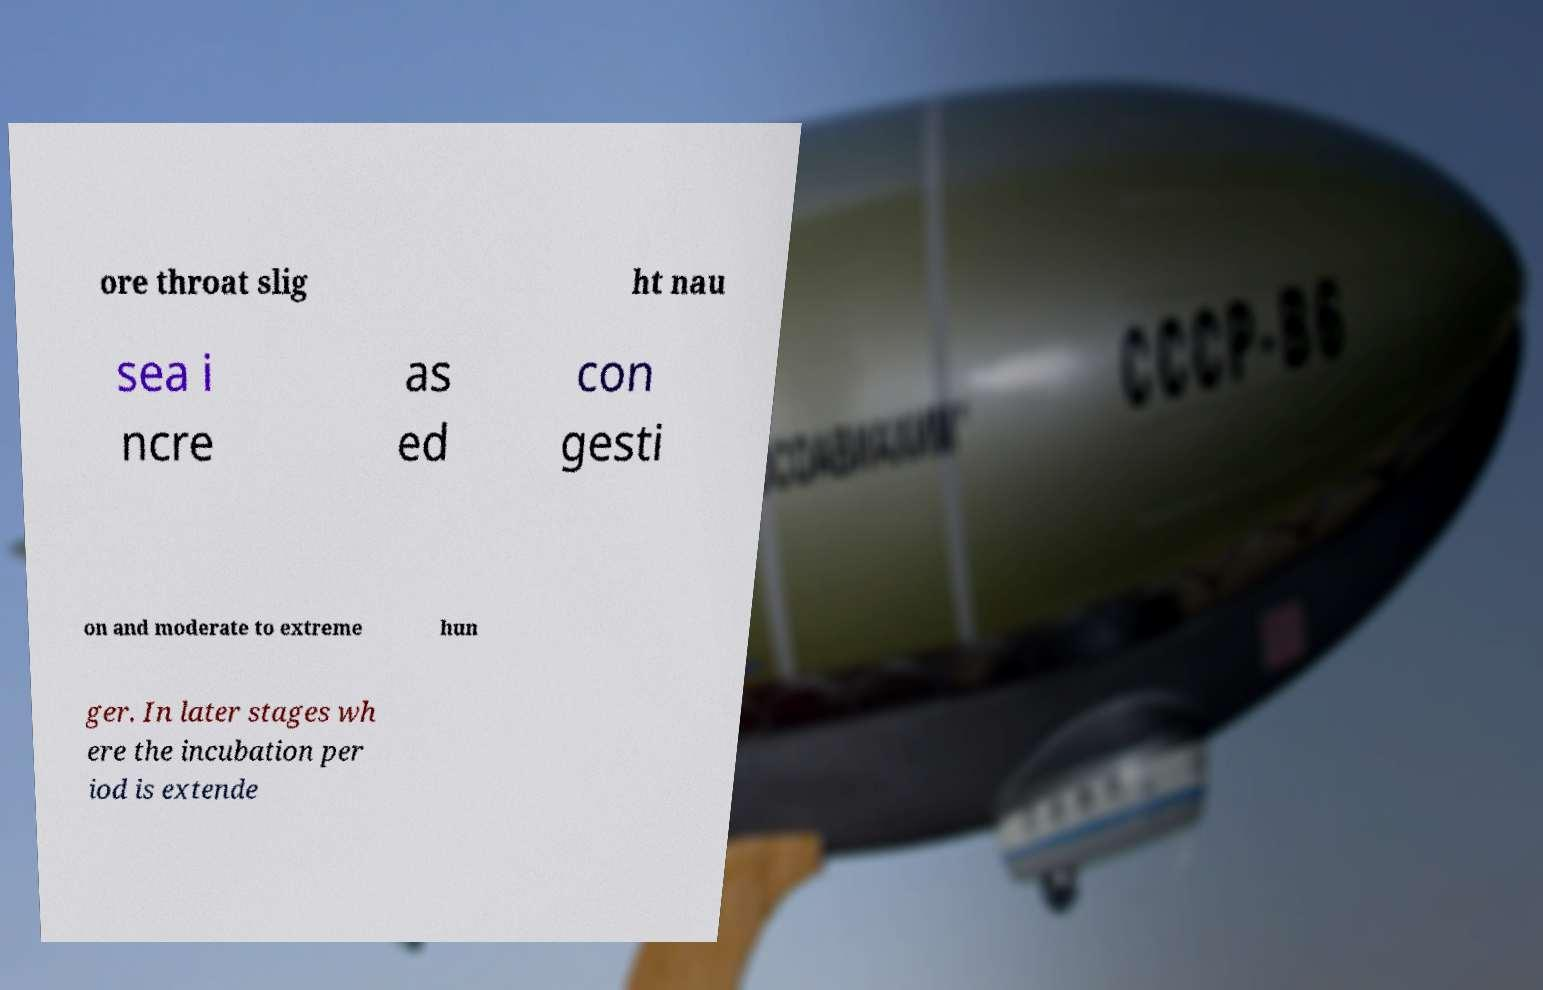I need the written content from this picture converted into text. Can you do that? ore throat slig ht nau sea i ncre as ed con gesti on and moderate to extreme hun ger. In later stages wh ere the incubation per iod is extende 